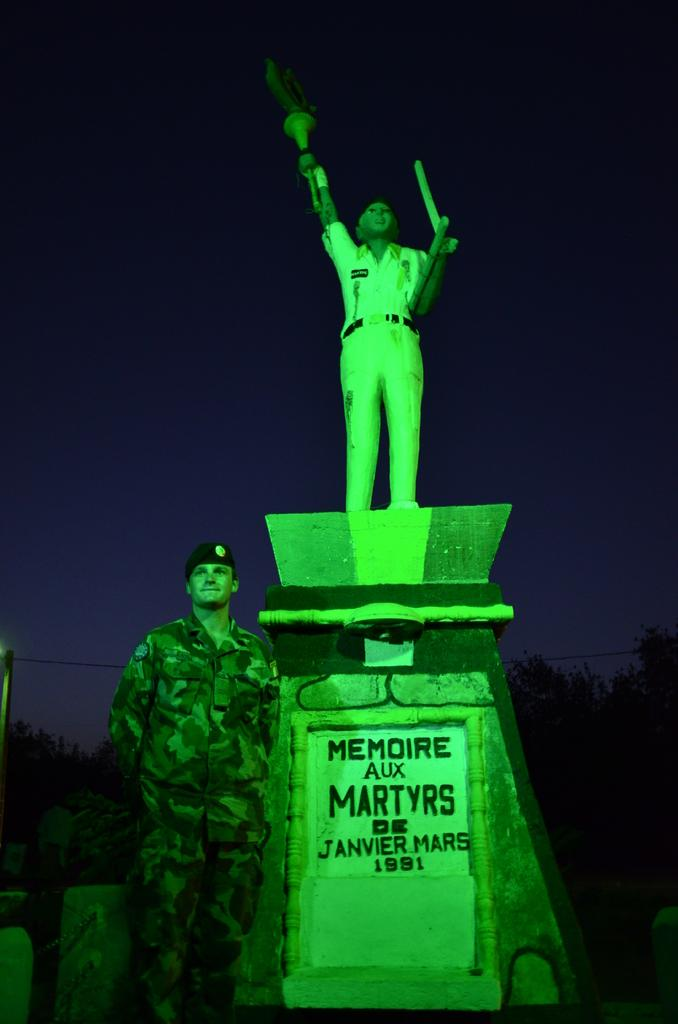What is the main subject of the image? There is a statue of a person in the image. What is the statue doing in the image? The statue is holding some objects. Where is the statue located? The statue is on a rock structure. What is written or depicted on the rock structure? There is text on the rock structure. Can you describe the person standing behind the statue? There is a person standing behind the statue. How would you describe the lighting or color of the background in the image? The background of the image is dark. What type of paint is being used by the person in the rainstorm in the image? There is no person in a rainstorm or paint present in the image; it features a statue on a rock structure with text and a person standing behind it. 